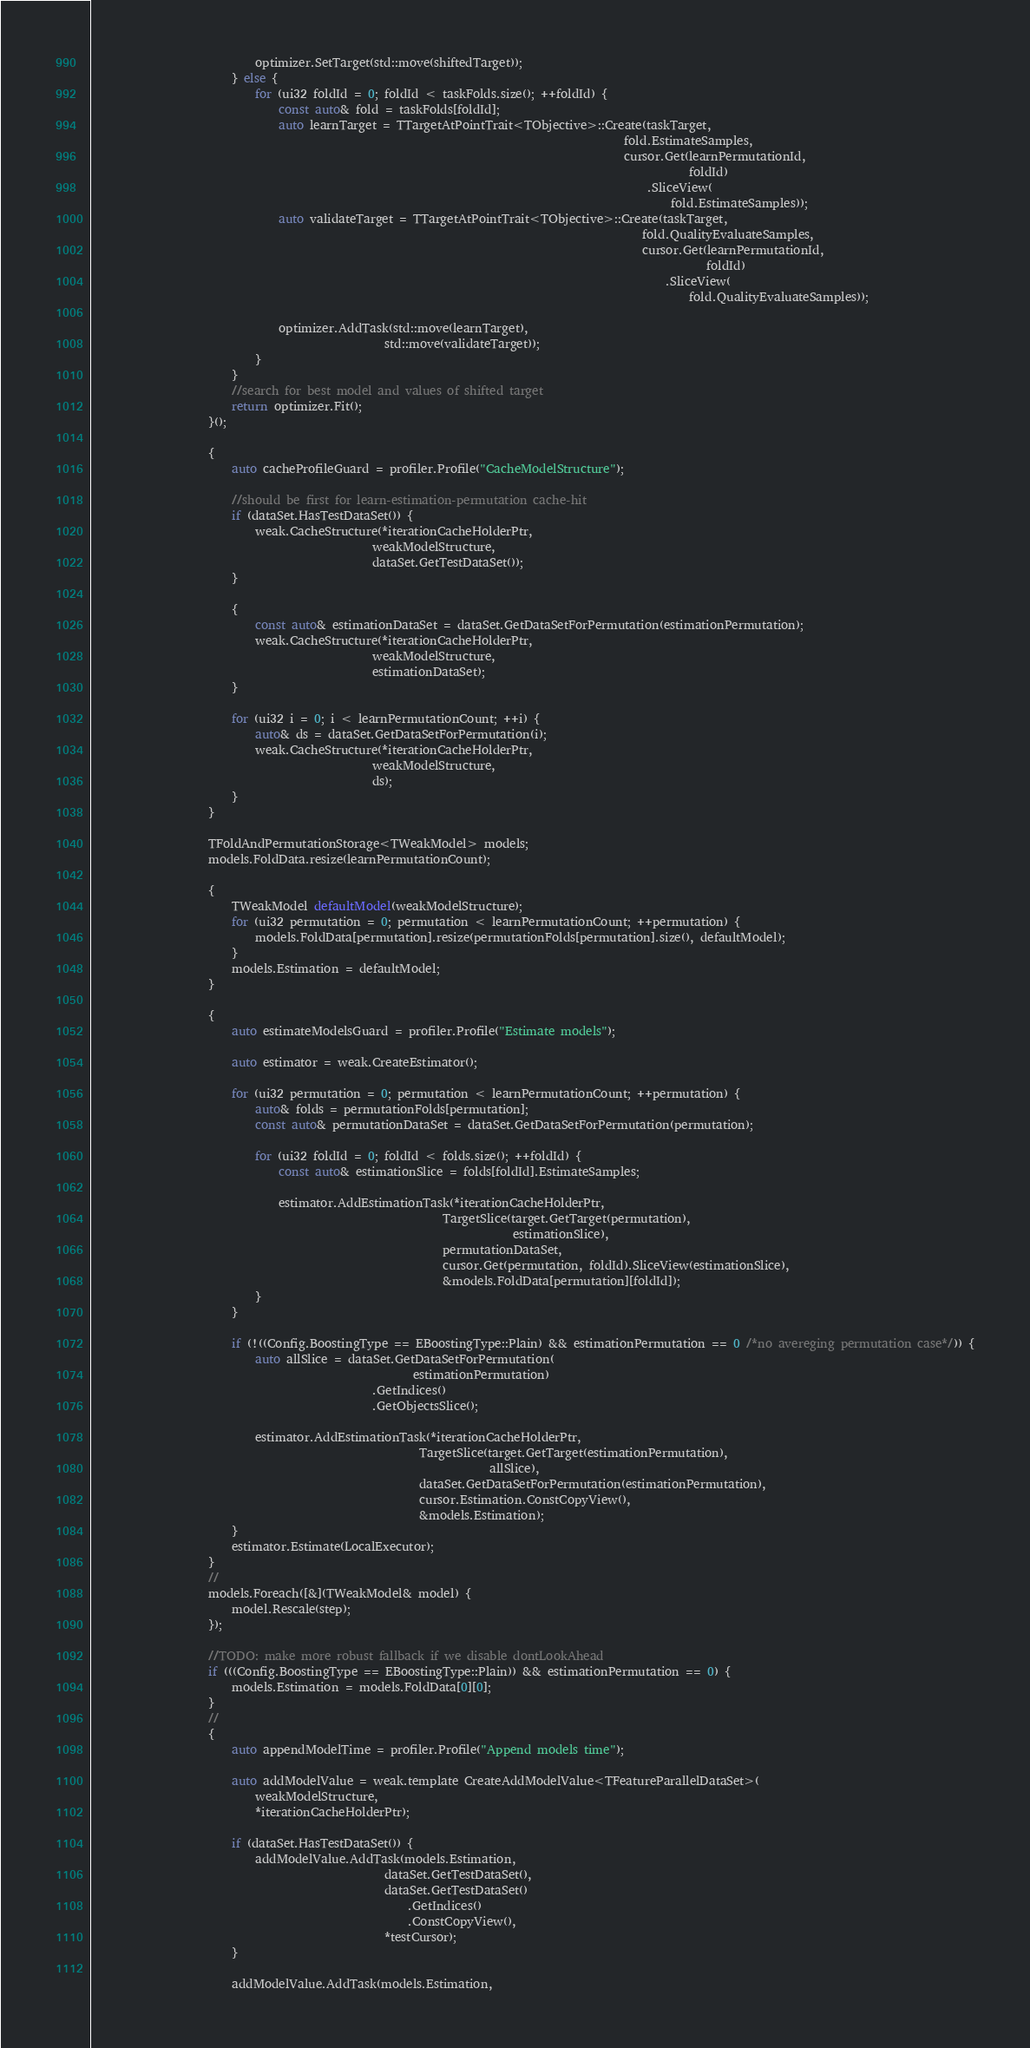<code> <loc_0><loc_0><loc_500><loc_500><_C_>                            optimizer.SetTarget(std::move(shiftedTarget));
                        } else {
                            for (ui32 foldId = 0; foldId < taskFolds.size(); ++foldId) {
                                const auto& fold = taskFolds[foldId];
                                auto learnTarget = TTargetAtPointTrait<TObjective>::Create(taskTarget,
                                                                                           fold.EstimateSamples,
                                                                                           cursor.Get(learnPermutationId,
                                                                                                      foldId)
                                                                                               .SliceView(
                                                                                                   fold.EstimateSamples));
                                auto validateTarget = TTargetAtPointTrait<TObjective>::Create(taskTarget,
                                                                                              fold.QualityEvaluateSamples,
                                                                                              cursor.Get(learnPermutationId,
                                                                                                         foldId)
                                                                                                  .SliceView(
                                                                                                      fold.QualityEvaluateSamples));

                                optimizer.AddTask(std::move(learnTarget),
                                                  std::move(validateTarget));
                            }
                        }
                        //search for best model and values of shifted target
                        return optimizer.Fit();
                    }();

                    {
                        auto cacheProfileGuard = profiler.Profile("CacheModelStructure");

                        //should be first for learn-estimation-permutation cache-hit
                        if (dataSet.HasTestDataSet()) {
                            weak.CacheStructure(*iterationCacheHolderPtr,
                                                weakModelStructure,
                                                dataSet.GetTestDataSet());
                        }

                        {
                            const auto& estimationDataSet = dataSet.GetDataSetForPermutation(estimationPermutation);
                            weak.CacheStructure(*iterationCacheHolderPtr,
                                                weakModelStructure,
                                                estimationDataSet);
                        }

                        for (ui32 i = 0; i < learnPermutationCount; ++i) {
                            auto& ds = dataSet.GetDataSetForPermutation(i);
                            weak.CacheStructure(*iterationCacheHolderPtr,
                                                weakModelStructure,
                                                ds);
                        }
                    }

                    TFoldAndPermutationStorage<TWeakModel> models;
                    models.FoldData.resize(learnPermutationCount);

                    {
                        TWeakModel defaultModel(weakModelStructure);
                        for (ui32 permutation = 0; permutation < learnPermutationCount; ++permutation) {
                            models.FoldData[permutation].resize(permutationFolds[permutation].size(), defaultModel);
                        }
                        models.Estimation = defaultModel;
                    }

                    {
                        auto estimateModelsGuard = profiler.Profile("Estimate models");

                        auto estimator = weak.CreateEstimator();

                        for (ui32 permutation = 0; permutation < learnPermutationCount; ++permutation) {
                            auto& folds = permutationFolds[permutation];
                            const auto& permutationDataSet = dataSet.GetDataSetForPermutation(permutation);

                            for (ui32 foldId = 0; foldId < folds.size(); ++foldId) {
                                const auto& estimationSlice = folds[foldId].EstimateSamples;

                                estimator.AddEstimationTask(*iterationCacheHolderPtr,
                                                            TargetSlice(target.GetTarget(permutation),
                                                                        estimationSlice),
                                                            permutationDataSet,
                                                            cursor.Get(permutation, foldId).SliceView(estimationSlice),
                                                            &models.FoldData[permutation][foldId]);
                            }
                        }

                        if (!((Config.BoostingType == EBoostingType::Plain) && estimationPermutation == 0 /*no avereging permutation case*/)) {
                            auto allSlice = dataSet.GetDataSetForPermutation(
                                                       estimationPermutation)
                                                .GetIndices()
                                                .GetObjectsSlice();

                            estimator.AddEstimationTask(*iterationCacheHolderPtr,
                                                        TargetSlice(target.GetTarget(estimationPermutation),
                                                                    allSlice),
                                                        dataSet.GetDataSetForPermutation(estimationPermutation),
                                                        cursor.Estimation.ConstCopyView(),
                                                        &models.Estimation);
                        }
                        estimator.Estimate(LocalExecutor);
                    }
                    //
                    models.Foreach([&](TWeakModel& model) {
                        model.Rescale(step);
                    });

                    //TODO: make more robust fallback if we disable dontLookAhead
                    if (((Config.BoostingType == EBoostingType::Plain)) && estimationPermutation == 0) {
                        models.Estimation = models.FoldData[0][0];
                    }
                    //
                    {
                        auto appendModelTime = profiler.Profile("Append models time");

                        auto addModelValue = weak.template CreateAddModelValue<TFeatureParallelDataSet>(
                            weakModelStructure,
                            *iterationCacheHolderPtr);

                        if (dataSet.HasTestDataSet()) {
                            addModelValue.AddTask(models.Estimation,
                                                  dataSet.GetTestDataSet(),
                                                  dataSet.GetTestDataSet()
                                                      .GetIndices()
                                                      .ConstCopyView(),
                                                  *testCursor);
                        }

                        addModelValue.AddTask(models.Estimation,</code> 